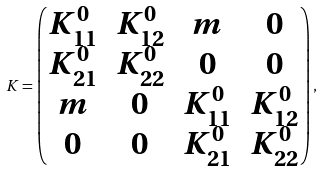Convert formula to latex. <formula><loc_0><loc_0><loc_500><loc_500>K = \left ( \begin{matrix} K ^ { 0 } _ { 1 1 } & K ^ { 0 } _ { 1 2 } & m & 0 \\ K ^ { 0 } _ { 2 1 } & K ^ { 0 } _ { 2 2 } & 0 & 0 \\ m & 0 & K ^ { 0 } _ { 1 1 } & K ^ { 0 } _ { 1 2 } \\ 0 & 0 & K ^ { 0 } _ { 2 1 } & K ^ { 0 } _ { 2 2 } \\ \end{matrix} \right ) ,</formula> 